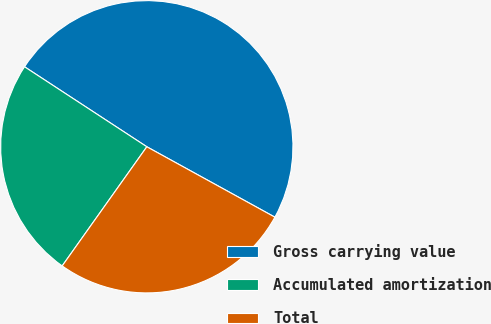Convert chart. <chart><loc_0><loc_0><loc_500><loc_500><pie_chart><fcel>Gross carrying value<fcel>Accumulated amortization<fcel>Total<nl><fcel>48.78%<fcel>24.39%<fcel>26.83%<nl></chart> 